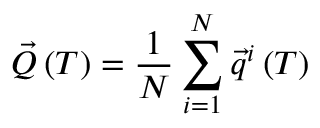Convert formula to latex. <formula><loc_0><loc_0><loc_500><loc_500>\vec { Q } \left ( T \right ) = \frac { 1 } { N } \sum _ { i = 1 } ^ { N } \vec { q } ^ { i } \left ( T \right )</formula> 